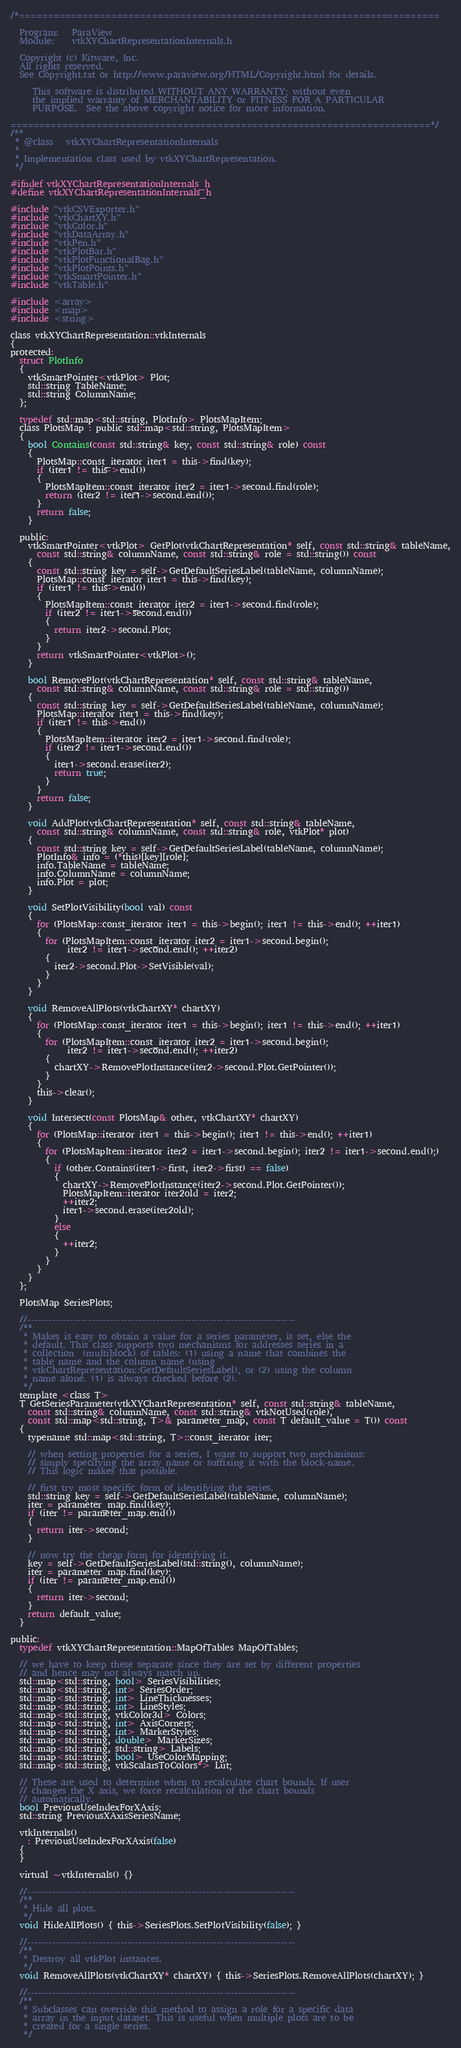<code> <loc_0><loc_0><loc_500><loc_500><_C_>/*=========================================================================

  Program:   ParaView
  Module:    vtkXYChartRepresentationInternals.h

  Copyright (c) Kitware, Inc.
  All rights reserved.
  See Copyright.txt or http://www.paraview.org/HTML/Copyright.html for details.

     This software is distributed WITHOUT ANY WARRANTY; without even
     the implied warranty of MERCHANTABILITY or FITNESS FOR A PARTICULAR
     PURPOSE.  See the above copyright notice for more information.

=========================================================================*/
/**
 * @class   vtkXYChartRepresentationInternals
 *
 * Implementation class used by vtkXYChartRepresentation.
 */

#ifndef vtkXYChartRepresentationInternals_h
#define vtkXYChartRepresentationInternals_h

#include "vtkCSVExporter.h"
#include "vtkChartXY.h"
#include "vtkColor.h"
#include "vtkDataArray.h"
#include "vtkPen.h"
#include "vtkPlotBar.h"
#include "vtkPlotFunctionalBag.h"
#include "vtkPlotPoints.h"
#include "vtkSmartPointer.h"
#include "vtkTable.h"

#include <array>
#include <map>
#include <string>

class vtkXYChartRepresentation::vtkInternals
{
protected:
  struct PlotInfo
  {
    vtkSmartPointer<vtkPlot> Plot;
    std::string TableName;
    std::string ColumnName;
  };

  typedef std::map<std::string, PlotInfo> PlotsMapItem;
  class PlotsMap : public std::map<std::string, PlotsMapItem>
  {
    bool Contains(const std::string& key, const std::string& role) const
    {
      PlotsMap::const_iterator iter1 = this->find(key);
      if (iter1 != this->end())
      {
        PlotsMapItem::const_iterator iter2 = iter1->second.find(role);
        return (iter2 != iter1->second.end());
      }
      return false;
    }

  public:
    vtkSmartPointer<vtkPlot> GetPlot(vtkChartRepresentation* self, const std::string& tableName,
      const std::string& columnName, const std::string& role = std::string()) const
    {
      const std::string key = self->GetDefaultSeriesLabel(tableName, columnName);
      PlotsMap::const_iterator iter1 = this->find(key);
      if (iter1 != this->end())
      {
        PlotsMapItem::const_iterator iter2 = iter1->second.find(role);
        if (iter2 != iter1->second.end())
        {
          return iter2->second.Plot;
        }
      }
      return vtkSmartPointer<vtkPlot>();
    }

    bool RemovePlot(vtkChartRepresentation* self, const std::string& tableName,
      const std::string& columnName, const std::string& role = std::string())
    {
      const std::string key = self->GetDefaultSeriesLabel(tableName, columnName);
      PlotsMap::iterator iter1 = this->find(key);
      if (iter1 != this->end())
      {
        PlotsMapItem::iterator iter2 = iter1->second.find(role);
        if (iter2 != iter1->second.end())
        {
          iter1->second.erase(iter2);
          return true;
        }
      }
      return false;
    }

    void AddPlot(vtkChartRepresentation* self, const std::string& tableName,
      const std::string& columnName, const std::string& role, vtkPlot* plot)
    {
      const std::string key = self->GetDefaultSeriesLabel(tableName, columnName);
      PlotInfo& info = (*this)[key][role];
      info.TableName = tableName;
      info.ColumnName = columnName;
      info.Plot = plot;
    }

    void SetPlotVisibility(bool val) const
    {
      for (PlotsMap::const_iterator iter1 = this->begin(); iter1 != this->end(); ++iter1)
      {
        for (PlotsMapItem::const_iterator iter2 = iter1->second.begin();
             iter2 != iter1->second.end(); ++iter2)
        {
          iter2->second.Plot->SetVisible(val);
        }
      }
    }

    void RemoveAllPlots(vtkChartXY* chartXY)
    {
      for (PlotsMap::const_iterator iter1 = this->begin(); iter1 != this->end(); ++iter1)
      {
        for (PlotsMapItem::const_iterator iter2 = iter1->second.begin();
             iter2 != iter1->second.end(); ++iter2)
        {
          chartXY->RemovePlotInstance(iter2->second.Plot.GetPointer());
        }
      }
      this->clear();
    }

    void Intersect(const PlotsMap& other, vtkChartXY* chartXY)
    {
      for (PlotsMap::iterator iter1 = this->begin(); iter1 != this->end(); ++iter1)
      {
        for (PlotsMapItem::iterator iter2 = iter1->second.begin(); iter2 != iter1->second.end();)
        {
          if (other.Contains(iter1->first, iter2->first) == false)
          {
            chartXY->RemovePlotInstance(iter2->second.Plot.GetPointer());
            PlotsMapItem::iterator iter2old = iter2;
            ++iter2;
            iter1->second.erase(iter2old);
          }
          else
          {
            ++iter2;
          }
        }
      }
    }
  };

  PlotsMap SeriesPlots;

  //---------------------------------------------------------------------------
  /**
   * Makes is easy to obtain a value for a series parameter, is set, else the
   * default. This class supports two mechanisms for addresses series in a
   * collection  (multiblock) of tables: (1) using a name that combines the
   * table name and the column name (using
   * vtkChartRepresentation::GetDefaultSeriesLabel), or (2) using the column
   * name alone. (1) is always checked before (2).
   */
  template <class T>
  T GetSeriesParameter(vtkXYChartRepresentation* self, const std::string& tableName,
    const std::string& columnName, const std::string& vtkNotUsed(role),
    const std::map<std::string, T>& parameter_map, const T default_value = T()) const
  {
    typename std::map<std::string, T>::const_iterator iter;

    // when setting properties for a series, I want to support two mechanisms:
    // simply specifying the array name or suffixing it with the block-name.
    // This logic makes that possible.

    // first try most specific form of identifying the series.
    std::string key = self->GetDefaultSeriesLabel(tableName, columnName);
    iter = parameter_map.find(key);
    if (iter != parameter_map.end())
    {
      return iter->second;
    }

    // now try the cheap form for identifying it.
    key = self->GetDefaultSeriesLabel(std::string(), columnName);
    iter = parameter_map.find(key);
    if (iter != parameter_map.end())
    {
      return iter->second;
    }
    return default_value;
  }

public:
  typedef vtkXYChartRepresentation::MapOfTables MapOfTables;

  // we have to keep these separate since they are set by different properties
  // and hence may not always match up.
  std::map<std::string, bool> SeriesVisibilities;
  std::map<std::string, int> SeriesOrder;
  std::map<std::string, int> LineThicknesses;
  std::map<std::string, int> LineStyles;
  std::map<std::string, vtkColor3d> Colors;
  std::map<std::string, int> AxisCorners;
  std::map<std::string, int> MarkerStyles;
  std::map<std::string, double> MarkerSizes;
  std::map<std::string, std::string> Labels;
  std::map<std::string, bool> UseColorMapping;
  std::map<std::string, vtkScalarsToColors*> Lut;

  // These are used to determine when to recalculate chart bounds. If user
  // changes the X axis, we force recalculation of the chart bounds
  // automatically.
  bool PreviousUseIndexForXAxis;
  std::string PreviousXAxisSeriesName;

  vtkInternals()
    : PreviousUseIndexForXAxis(false)
  {
  }

  virtual ~vtkInternals() {}

  //---------------------------------------------------------------------------
  /**
   * Hide all plots.
   */
  void HideAllPlots() { this->SeriesPlots.SetPlotVisibility(false); }

  //---------------------------------------------------------------------------
  /**
   * Destroy all vtkPlot instances.
   */
  void RemoveAllPlots(vtkChartXY* chartXY) { this->SeriesPlots.RemoveAllPlots(chartXY); }

  //---------------------------------------------------------------------------
  /**
   * Subclasses can override this method to assign a role for a specific data
   * array in the input dataset. This is useful when multiple plots are to be
   * created for a single series.
   */</code> 